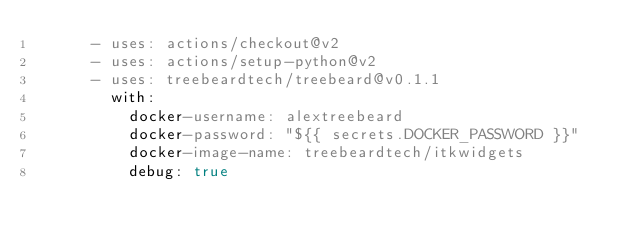Convert code to text. <code><loc_0><loc_0><loc_500><loc_500><_YAML_>      - uses: actions/checkout@v2
      - uses: actions/setup-python@v2
      - uses: treebeardtech/treebeard@v0.1.1
        with:
          docker-username: alextreebeard
          docker-password: "${{ secrets.DOCKER_PASSWORD }}"
          docker-image-name: treebeardtech/itkwidgets
          debug: true
</code> 